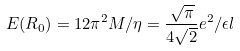<formula> <loc_0><loc_0><loc_500><loc_500>E ( R _ { 0 } ) = 1 2 \pi ^ { 2 } M / \eta = \frac { \sqrt { \pi } } { 4 \sqrt { 2 } } e ^ { 2 } / \epsilon l</formula> 